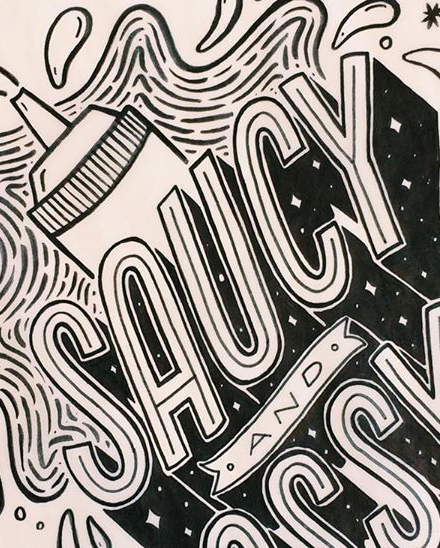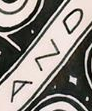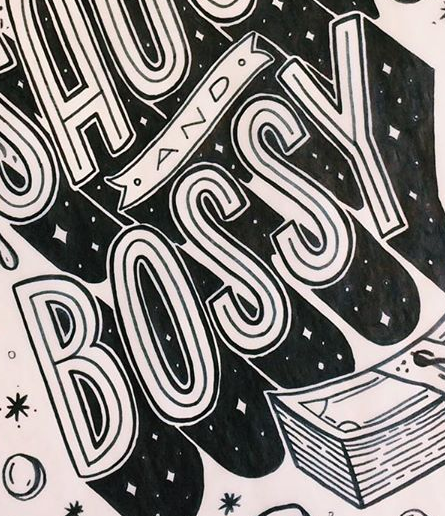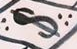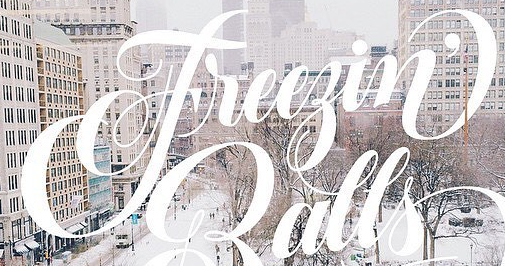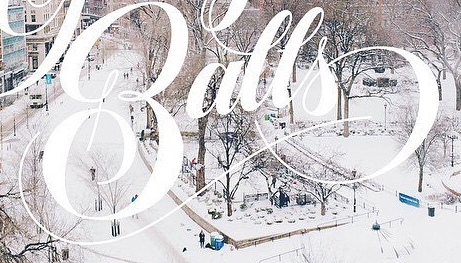What text appears in these images from left to right, separated by a semicolon? SAUCY; AND; BOSSY; $; Freegin'; Balls 